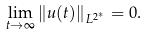<formula> <loc_0><loc_0><loc_500><loc_500>\lim _ { t \rightarrow \infty } \| u ( t ) \| _ { L ^ { 2 ^ { * } } } = 0 .</formula> 